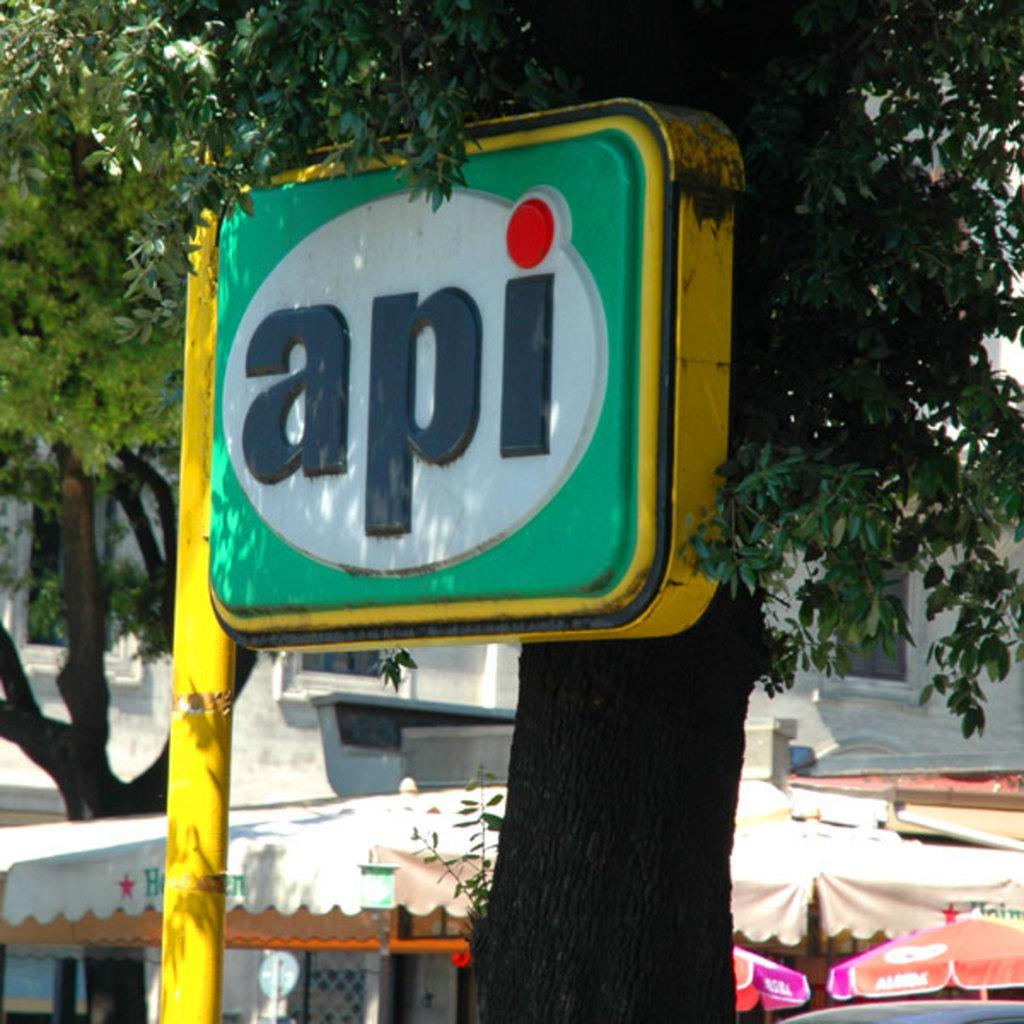What is the main object in the image? There is a colorful board in the image. Where is the board positioned in relation to the tree? The board is located to the side of a tree. What can be seen in the background of the image? There are tents and a building visible in the background of the image. How many eggs are on the colorful board in the image? There are no eggs present on the colorful board in the image. 